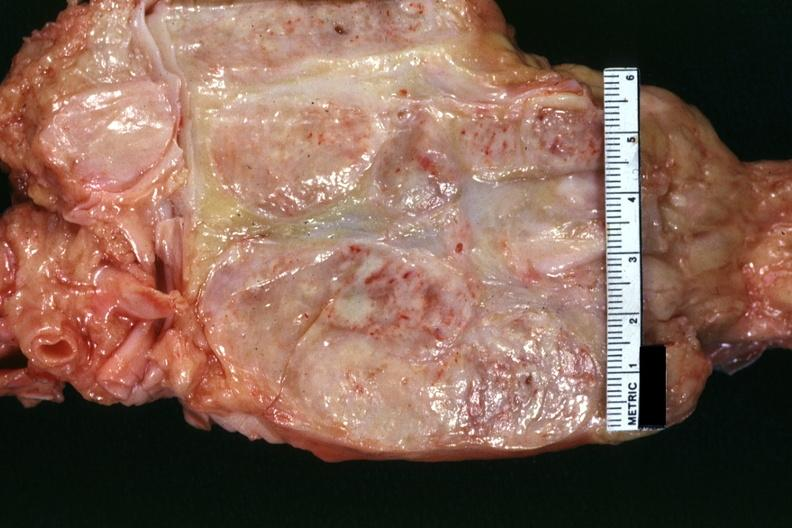what is present?
Answer the question using a single word or phrase. Hodgkins disease 